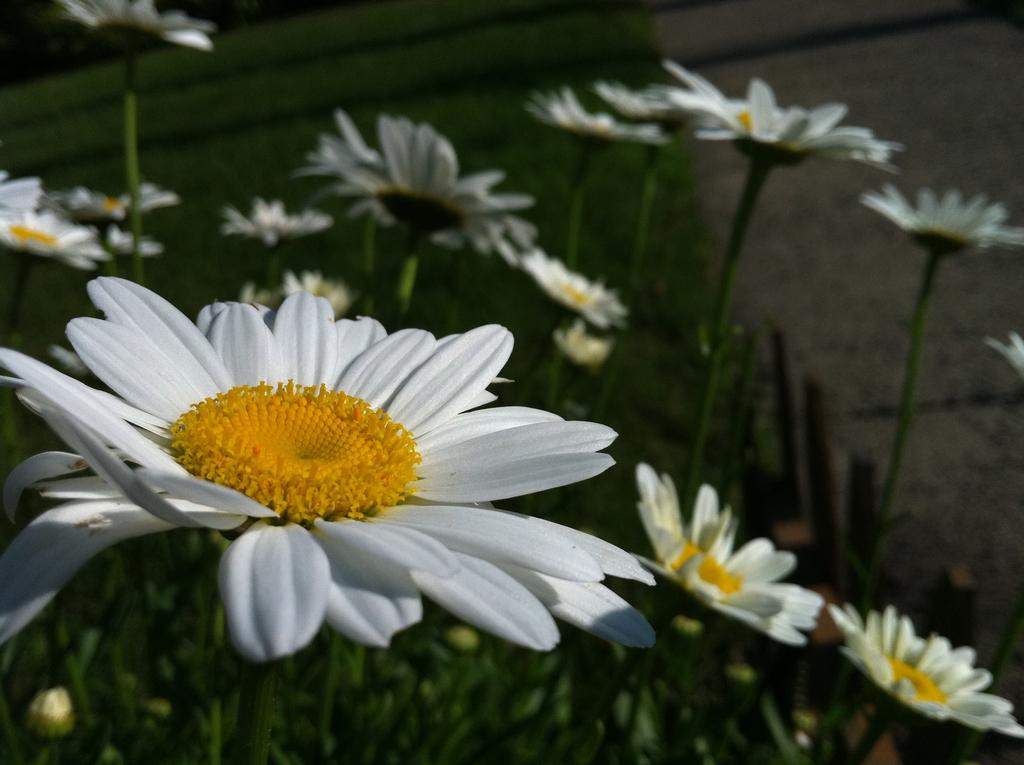What is located on the left side of the image? There is a flower on the left side of the image. What can be seen in the background of the image? There are plants and flowers in the background of the image. What type of rhythm can be heard coming from the leg in the image? There is no leg or rhythm present in the image; it features a flower and plants in the background. 